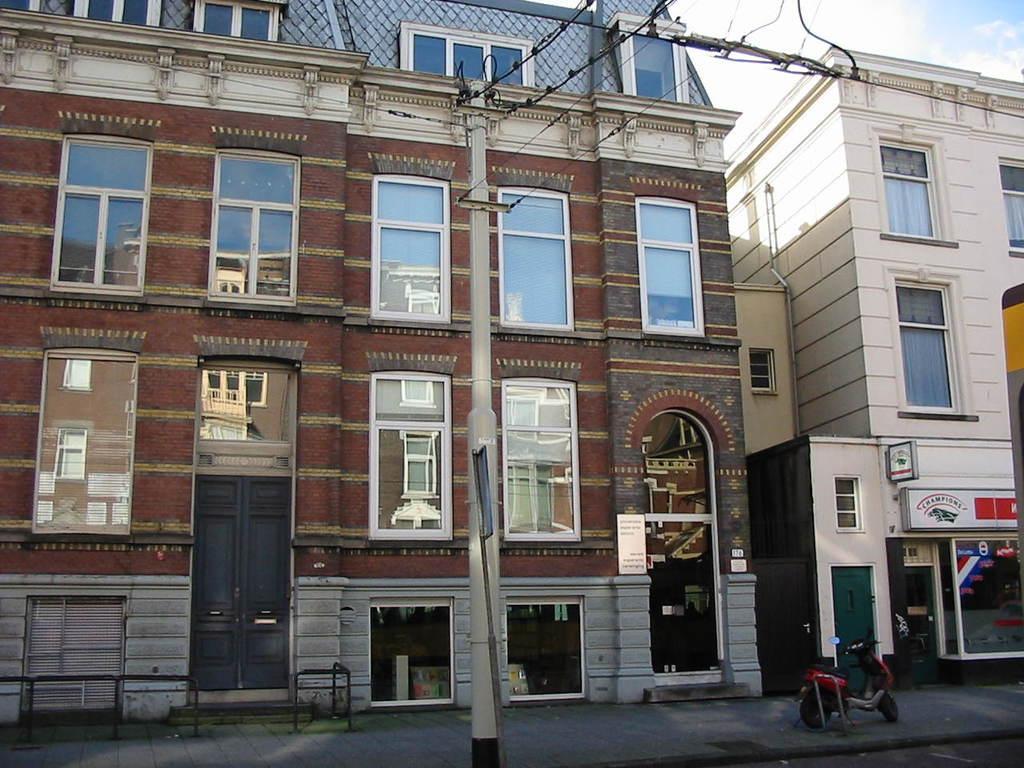Describe this image in one or two sentences. In this image in the front there is a pole and there are wires on the pole. In the background there are buildings and in front of the building on the right side there is a vehicle and the sky is cloudy. 